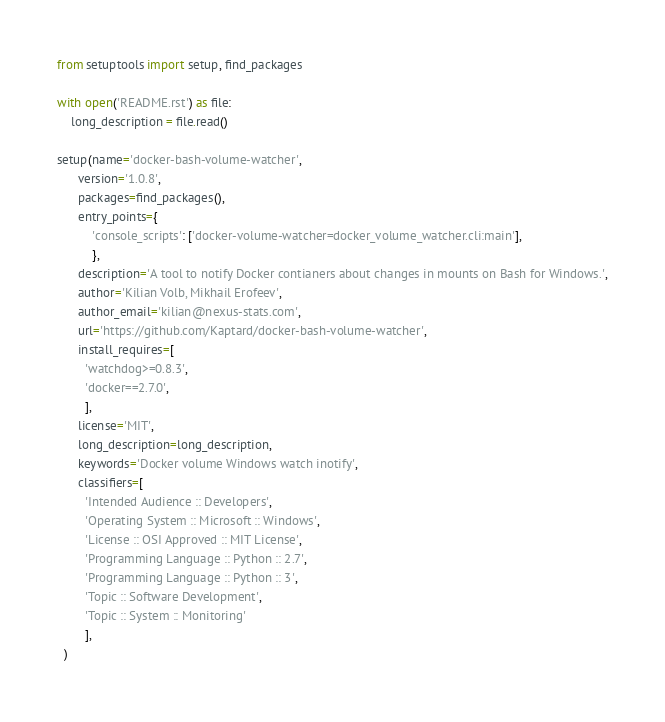Convert code to text. <code><loc_0><loc_0><loc_500><loc_500><_Python_>from setuptools import setup, find_packages

with open('README.rst') as file:
    long_description = file.read()

setup(name='docker-bash-volume-watcher',
      version='1.0.8',
      packages=find_packages(),
      entry_points={
          'console_scripts': ['docker-volume-watcher=docker_volume_watcher.cli:main'],
          },
      description='A tool to notify Docker contianers about changes in mounts on Bash for Windows.',
      author='Kilian Volb, Mikhail Erofeev',
      author_email='kilian@nexus-stats.com',
      url='https://github.com/Kaptard/docker-bash-volume-watcher',
      install_requires=[
        'watchdog>=0.8.3',
        'docker==2.7.0',
        ],
      license='MIT',
      long_description=long_description,
      keywords='Docker volume Windows watch inotify',
      classifiers=[
        'Intended Audience :: Developers',
        'Operating System :: Microsoft :: Windows',
        'License :: OSI Approved :: MIT License',
        'Programming Language :: Python :: 2.7',
        'Programming Language :: Python :: 3',
        'Topic :: Software Development',
        'Topic :: System :: Monitoring'
        ],
  )
</code> 